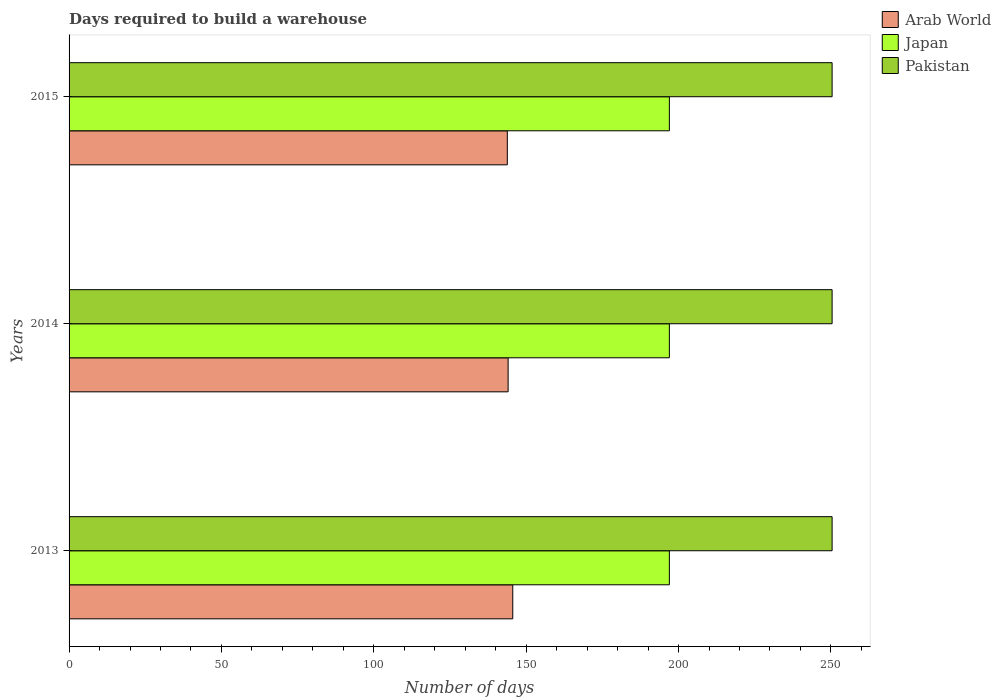How many different coloured bars are there?
Keep it short and to the point. 3. How many groups of bars are there?
Your answer should be compact. 3. Are the number of bars per tick equal to the number of legend labels?
Make the answer very short. Yes. How many bars are there on the 1st tick from the bottom?
Your answer should be compact. 3. In how many cases, is the number of bars for a given year not equal to the number of legend labels?
Provide a succinct answer. 0. What is the days required to build a warehouse in in Pakistan in 2015?
Provide a short and direct response. 250.4. Across all years, what is the maximum days required to build a warehouse in in Japan?
Offer a very short reply. 197. Across all years, what is the minimum days required to build a warehouse in in Arab World?
Your response must be concise. 143.82. In which year was the days required to build a warehouse in in Arab World minimum?
Offer a very short reply. 2015. What is the total days required to build a warehouse in in Japan in the graph?
Your response must be concise. 591. What is the difference between the days required to build a warehouse in in Japan in 2014 and the days required to build a warehouse in in Arab World in 2015?
Give a very brief answer. 53.18. What is the average days required to build a warehouse in in Japan per year?
Keep it short and to the point. 197. In the year 2013, what is the difference between the days required to build a warehouse in in Japan and days required to build a warehouse in in Pakistan?
Your answer should be very brief. -53.4. Is the days required to build a warehouse in in Japan in 2014 less than that in 2015?
Your answer should be very brief. No. Is the difference between the days required to build a warehouse in in Japan in 2014 and 2015 greater than the difference between the days required to build a warehouse in in Pakistan in 2014 and 2015?
Keep it short and to the point. No. What is the difference between the highest and the second highest days required to build a warehouse in in Pakistan?
Provide a short and direct response. 0. What is the difference between the highest and the lowest days required to build a warehouse in in Arab World?
Offer a terse response. 1.79. In how many years, is the days required to build a warehouse in in Pakistan greater than the average days required to build a warehouse in in Pakistan taken over all years?
Keep it short and to the point. 0. What does the 3rd bar from the top in 2014 represents?
Ensure brevity in your answer.  Arab World. How many years are there in the graph?
Make the answer very short. 3. Where does the legend appear in the graph?
Provide a short and direct response. Top right. How many legend labels are there?
Provide a short and direct response. 3. What is the title of the graph?
Ensure brevity in your answer.  Days required to build a warehouse. Does "Palau" appear as one of the legend labels in the graph?
Your answer should be compact. No. What is the label or title of the X-axis?
Ensure brevity in your answer.  Number of days. What is the Number of days of Arab World in 2013?
Your answer should be very brief. 145.61. What is the Number of days in Japan in 2013?
Make the answer very short. 197. What is the Number of days in Pakistan in 2013?
Provide a succinct answer. 250.4. What is the Number of days of Arab World in 2014?
Provide a succinct answer. 144.08. What is the Number of days of Japan in 2014?
Offer a terse response. 197. What is the Number of days in Pakistan in 2014?
Offer a terse response. 250.4. What is the Number of days in Arab World in 2015?
Keep it short and to the point. 143.82. What is the Number of days of Japan in 2015?
Give a very brief answer. 197. What is the Number of days of Pakistan in 2015?
Your answer should be very brief. 250.4. Across all years, what is the maximum Number of days of Arab World?
Give a very brief answer. 145.61. Across all years, what is the maximum Number of days of Japan?
Your answer should be very brief. 197. Across all years, what is the maximum Number of days in Pakistan?
Offer a very short reply. 250.4. Across all years, what is the minimum Number of days of Arab World?
Ensure brevity in your answer.  143.82. Across all years, what is the minimum Number of days of Japan?
Offer a very short reply. 197. Across all years, what is the minimum Number of days in Pakistan?
Provide a succinct answer. 250.4. What is the total Number of days of Arab World in the graph?
Your answer should be very brief. 433.5. What is the total Number of days in Japan in the graph?
Keep it short and to the point. 591. What is the total Number of days in Pakistan in the graph?
Give a very brief answer. 751.2. What is the difference between the Number of days of Arab World in 2013 and that in 2014?
Provide a short and direct response. 1.53. What is the difference between the Number of days in Japan in 2013 and that in 2014?
Your response must be concise. 0. What is the difference between the Number of days in Arab World in 2013 and that in 2015?
Your answer should be very brief. 1.79. What is the difference between the Number of days of Arab World in 2014 and that in 2015?
Ensure brevity in your answer.  0.26. What is the difference between the Number of days in Japan in 2014 and that in 2015?
Offer a very short reply. 0. What is the difference between the Number of days in Pakistan in 2014 and that in 2015?
Give a very brief answer. 0. What is the difference between the Number of days in Arab World in 2013 and the Number of days in Japan in 2014?
Your response must be concise. -51.39. What is the difference between the Number of days of Arab World in 2013 and the Number of days of Pakistan in 2014?
Provide a succinct answer. -104.79. What is the difference between the Number of days in Japan in 2013 and the Number of days in Pakistan in 2014?
Keep it short and to the point. -53.4. What is the difference between the Number of days in Arab World in 2013 and the Number of days in Japan in 2015?
Keep it short and to the point. -51.39. What is the difference between the Number of days of Arab World in 2013 and the Number of days of Pakistan in 2015?
Offer a terse response. -104.79. What is the difference between the Number of days in Japan in 2013 and the Number of days in Pakistan in 2015?
Offer a very short reply. -53.4. What is the difference between the Number of days of Arab World in 2014 and the Number of days of Japan in 2015?
Offer a very short reply. -52.92. What is the difference between the Number of days in Arab World in 2014 and the Number of days in Pakistan in 2015?
Ensure brevity in your answer.  -106.32. What is the difference between the Number of days in Japan in 2014 and the Number of days in Pakistan in 2015?
Ensure brevity in your answer.  -53.4. What is the average Number of days in Arab World per year?
Provide a succinct answer. 144.5. What is the average Number of days of Japan per year?
Offer a terse response. 197. What is the average Number of days in Pakistan per year?
Make the answer very short. 250.4. In the year 2013, what is the difference between the Number of days of Arab World and Number of days of Japan?
Offer a very short reply. -51.39. In the year 2013, what is the difference between the Number of days in Arab World and Number of days in Pakistan?
Keep it short and to the point. -104.79. In the year 2013, what is the difference between the Number of days of Japan and Number of days of Pakistan?
Offer a terse response. -53.4. In the year 2014, what is the difference between the Number of days of Arab World and Number of days of Japan?
Offer a very short reply. -52.92. In the year 2014, what is the difference between the Number of days of Arab World and Number of days of Pakistan?
Make the answer very short. -106.32. In the year 2014, what is the difference between the Number of days in Japan and Number of days in Pakistan?
Provide a short and direct response. -53.4. In the year 2015, what is the difference between the Number of days of Arab World and Number of days of Japan?
Your answer should be very brief. -53.18. In the year 2015, what is the difference between the Number of days in Arab World and Number of days in Pakistan?
Your answer should be very brief. -106.58. In the year 2015, what is the difference between the Number of days in Japan and Number of days in Pakistan?
Give a very brief answer. -53.4. What is the ratio of the Number of days of Arab World in 2013 to that in 2014?
Offer a very short reply. 1.01. What is the ratio of the Number of days of Pakistan in 2013 to that in 2014?
Give a very brief answer. 1. What is the ratio of the Number of days in Arab World in 2013 to that in 2015?
Ensure brevity in your answer.  1.01. What is the ratio of the Number of days of Japan in 2013 to that in 2015?
Your answer should be compact. 1. What is the ratio of the Number of days of Arab World in 2014 to that in 2015?
Your answer should be very brief. 1. What is the difference between the highest and the second highest Number of days of Arab World?
Keep it short and to the point. 1.53. What is the difference between the highest and the second highest Number of days of Japan?
Your answer should be very brief. 0. What is the difference between the highest and the second highest Number of days of Pakistan?
Your response must be concise. 0. What is the difference between the highest and the lowest Number of days in Arab World?
Keep it short and to the point. 1.79. What is the difference between the highest and the lowest Number of days in Japan?
Provide a succinct answer. 0. 